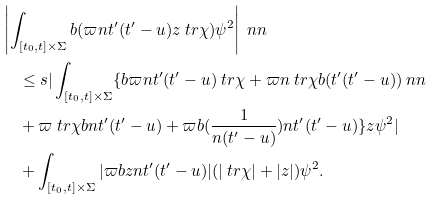<formula> <loc_0><loc_0><loc_500><loc_500>& \left | \int _ { [ t _ { 0 } , t ] \times \Sigma } \L b ( \varpi n t ^ { \prime } ( t ^ { \prime } - u ) z \ t r \chi ) \psi ^ { 2 } \right | \ n n \\ & \quad \leq s | \int _ { [ t _ { 0 } , t ] \times \Sigma } \{ \L b \varpi n t ^ { \prime } ( t ^ { \prime } - u ) \ t r \chi + \varpi n \ t r \chi \L b ( t ^ { \prime } ( t ^ { \prime } - u ) ) \ n n \\ & \quad + \varpi \ t r \chi \L b n t ^ { \prime } ( t ^ { \prime } - u ) + \varpi \L b ( \frac { 1 } { n ( t ^ { \prime } - u ) } ) n t ^ { \prime } ( t ^ { \prime } - u ) \} z \psi ^ { 2 } | \\ & \quad + \int _ { [ t _ { 0 } , t ] \times \Sigma } | \varpi \L b z n t ^ { \prime } ( t ^ { \prime } - u ) | ( | \ t r \chi | + | z | ) \psi ^ { 2 } .</formula> 